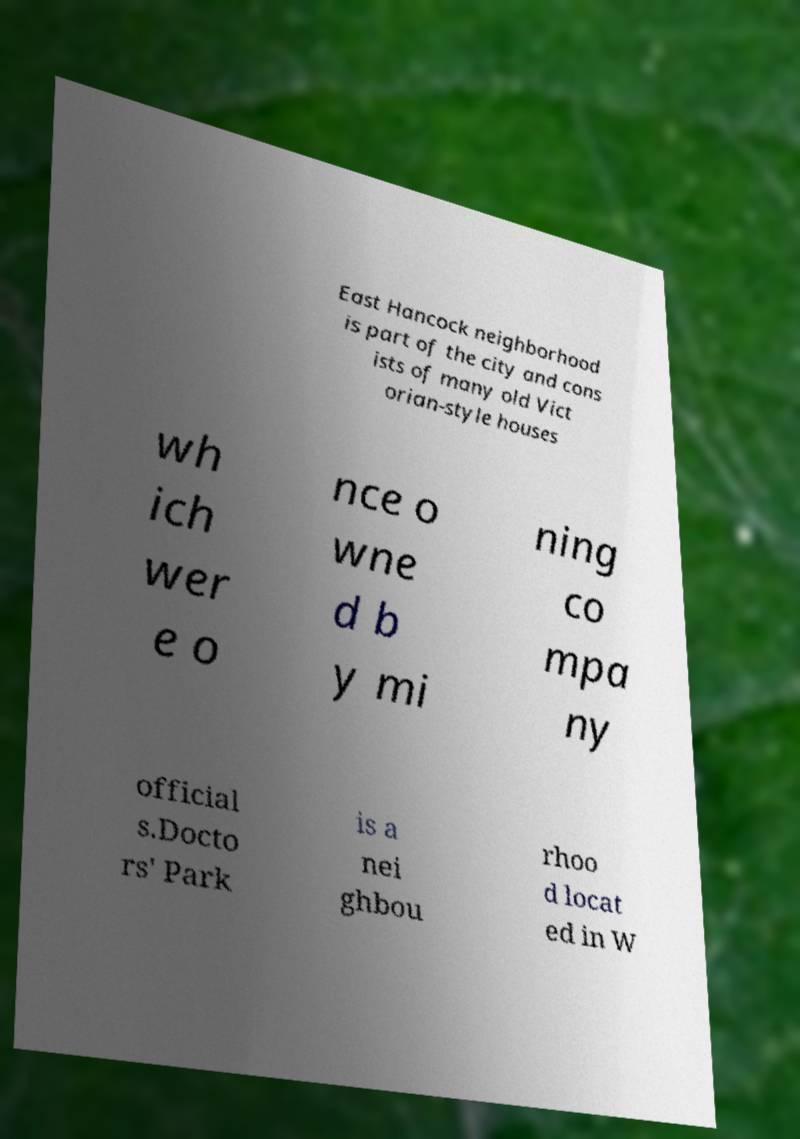For documentation purposes, I need the text within this image transcribed. Could you provide that? East Hancock neighborhood is part of the city and cons ists of many old Vict orian-style houses wh ich wer e o nce o wne d b y mi ning co mpa ny official s.Docto rs' Park is a nei ghbou rhoo d locat ed in W 